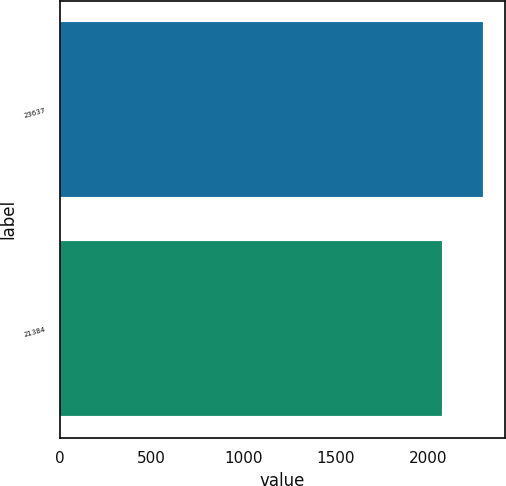<chart> <loc_0><loc_0><loc_500><loc_500><bar_chart><fcel>23637<fcel>21384<nl><fcel>2302.5<fcel>2076.5<nl></chart> 